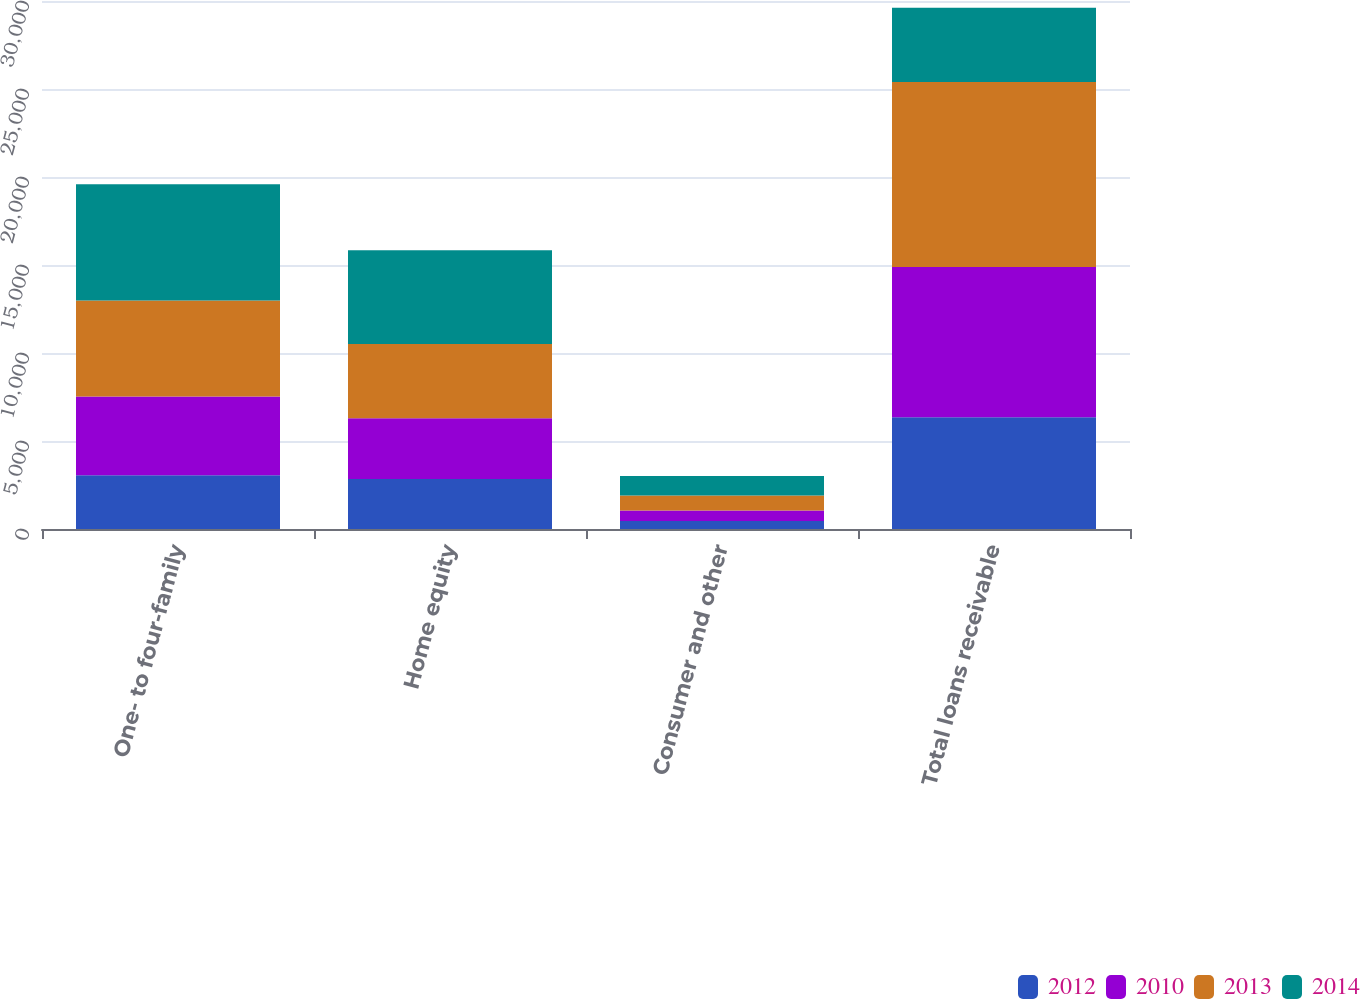Convert chart to OTSL. <chart><loc_0><loc_0><loc_500><loc_500><stacked_bar_chart><ecel><fcel>One- to four-family<fcel>Home equity<fcel>Consumer and other<fcel>Total loans receivable<nl><fcel>2012<fcel>3060<fcel>2834<fcel>455<fcel>6349<nl><fcel>2010<fcel>4475<fcel>3454<fcel>602<fcel>8531<nl><fcel>2013<fcel>5442<fcel>4224<fcel>845<fcel>10511<nl><fcel>2014<fcel>6616<fcel>5329<fcel>1113<fcel>4224<nl></chart> 